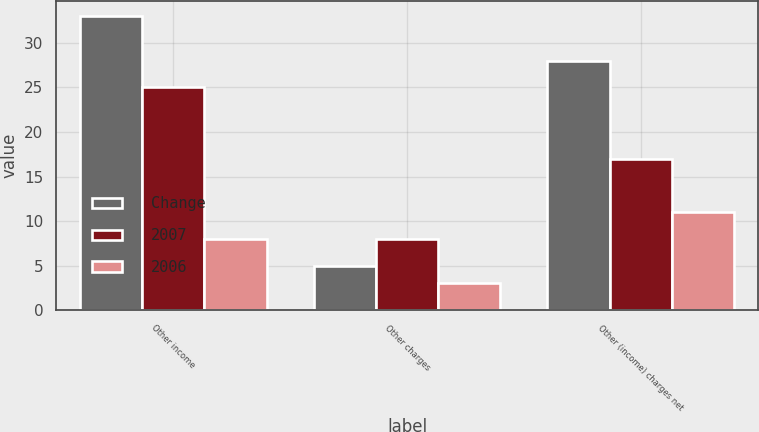Convert chart to OTSL. <chart><loc_0><loc_0><loc_500><loc_500><stacked_bar_chart><ecel><fcel>Other income<fcel>Other charges<fcel>Other (income) charges net<nl><fcel>Change<fcel>33<fcel>5<fcel>28<nl><fcel>2007<fcel>25<fcel>8<fcel>17<nl><fcel>2006<fcel>8<fcel>3<fcel>11<nl></chart> 